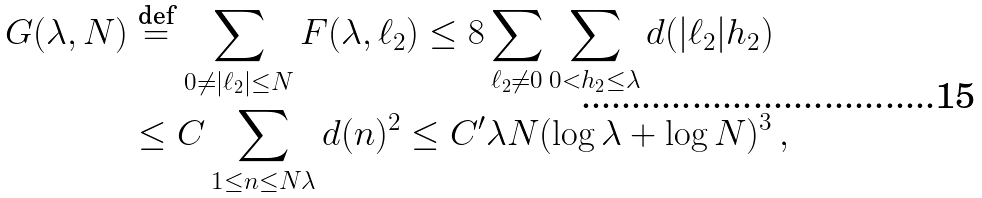Convert formula to latex. <formula><loc_0><loc_0><loc_500><loc_500>G ( \lambda , N ) & \stackrel { \text {def} } { = } \sum _ { 0 \neq | \ell _ { 2 } | \leq N } F ( { \lambda , \ell _ { 2 } } ) \leq 8 \sum _ { \ell _ { 2 } \neq 0 } \sum _ { 0 < h _ { 2 } \leq \lambda } d ( | \ell _ { 2 } | h _ { 2 } ) \\ & \leq C \sum _ { 1 \leq n \leq N \lambda } d ( n ) ^ { 2 } \leq C ^ { \prime } \lambda N ( \log \lambda + \log N ) ^ { 3 } \, ,</formula> 